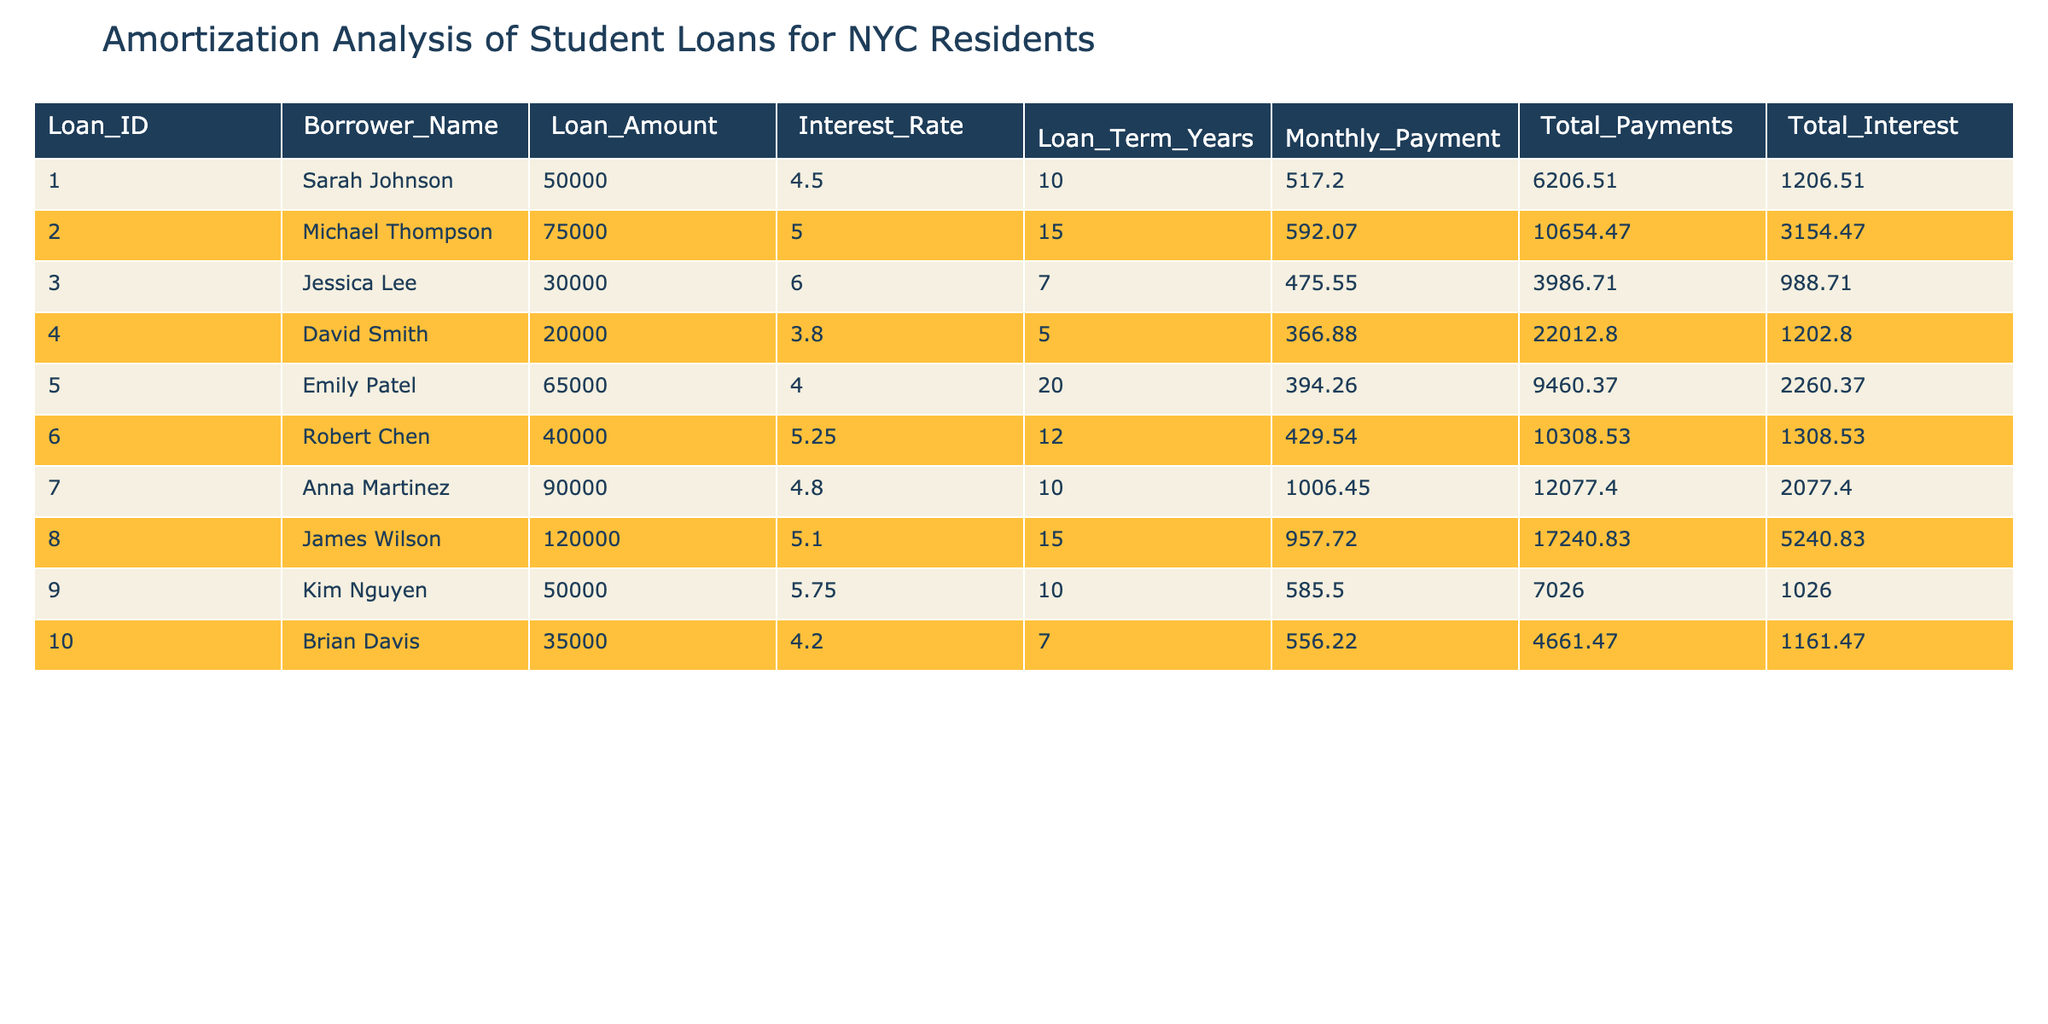What is the highest loan amount in the table? From the table, I identify the loan amounts for each borrower: Sarah Johnson has 50,000, Michael Thompson has 75,000, Jessica Lee has 30,000, David Smith has 20,000, Emily Patel has 65,000, Robert Chen has 40,000, Anna Martinez has 90,000, James Wilson has 120,000, Kim Nguyen has 50,000, and Brian Davis has 35,000. The highest value among these is 120,000, held by James Wilson.
Answer: 120000 Who has the lowest total interest paid? Looking at the total interest paid for each loan, Sarah Johnson paid 1,206.51, Michael Thompson paid 3,154.47, Jessica Lee paid 988.71, David Smith paid 1,202.80, Emily Patel paid 2,260.37, Robert Chen paid 1,308.53, Anna Martinez paid 2,077.40, James Wilson paid 5,240.83, Kim Nguyen paid 1,026.00, and Brian Davis paid 1,161.47. The lowest value is 988.71, associated with Jessica Lee.
Answer: Jessica Lee What is the average monthly payment across all loans? I add the monthly payments: 517.20 + 592.07 + 475.55 + 366.88 + 394.26 + 429.54 + 1006.45 + 957.72 + 585.50 + 556.22 = 5101.67. Then, I divide this sum by the number of loans, which is 10. Therefore, the average monthly payment is 5101.67 / 10 = 510.17.
Answer: 510.17 Is there any borrower paying an interest rate lower than 4%? By looking at the interest rates in the table, I see that Sarah Johnson has an interest rate of 4.5, Michael Thompson has 5.0, Jessica Lee has 6.0, David Smith has 3.8, Emily Patel has 4.0, Robert Chen has 5.25, Anna Martinez has 4.8, James Wilson has 5.1, Kim Nguyen has 5.75, and Brian Davis has 4.2. Only David Smith's rate is below 4%, so the answer is yes.
Answer: Yes What is the total amount paid by Emily Patel? To find Emily Patel's total amount paid, I refer to the table where it states her total payments as 9460.37. This value is already provided in the table, so there's no need for further calculations.
Answer: 9460.37 Which loan term has the highest average monthly payment? First, I categorize loans by their terms: 5 years (David Smith and Emily Patel), 7 years (Jessica Lee and Brian Davis), 10 years (Sarah Johnson, Anna Martinez, and Kim Nguyen), and 15 years (Michael Thompson and James Wilson). I calculate their average monthly payments: 5 years: (366.88 + 394.26) / 2 = 380.57, 7 years: (475.55 + 556.22) / 2 = 515.89, 10 years: (517.20 + 1006.45 + 585.50) / 3 = 703.72, and 15 years: (592.07 + 957.72) / 2 = 774.89. The highest average is 774.89 for the 15-year loans.
Answer: 15 years Does any borrower have a loan with a term shorter than 7 years? Checking the loan terms, I see Jessica Lee has a 7-year loan, while others have terms of 5, 10, 12, 15, and 20 years. Since the lowest term in this data is 5 years (for David Smith), the answer is yes.
Answer: Yes Which borrower has the longest loan term, and what is that term? I review the loan terms: Sarah Johnson has 10 years, Michael Thompson has 15 years, Jessica Lee has 7 years, David Smith has 5 years, Emily Patel has 20 years, Robert Chen has 12 years, Anna Martinez has 10 years, James Wilson has 15 years, Kim Nguyen has 10 years, and Brian Davis has 7 years. Emily Patel has the longest term of 20 years.
Answer: Emily Patel, 20 years 